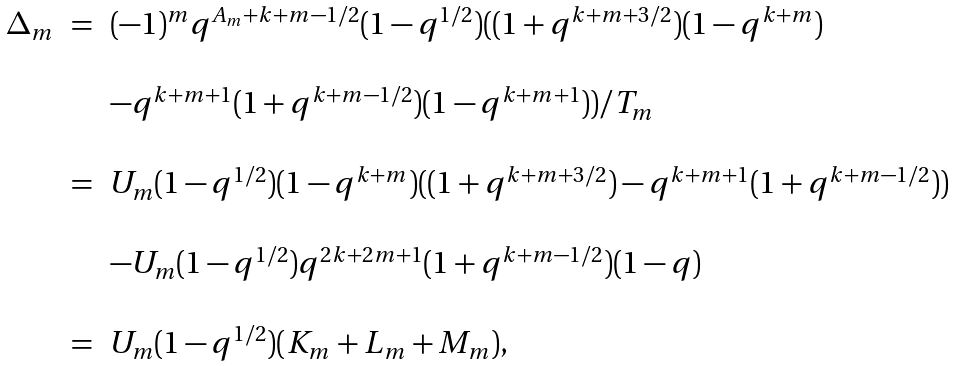<formula> <loc_0><loc_0><loc_500><loc_500>\begin{array} { c c l } \Delta _ { m } & = & ( - 1 ) ^ { m } q ^ { A _ { m } + k + m - 1 / 2 } ( 1 - q ^ { 1 / 2 } ) ( ( 1 + q ^ { k + m + 3 / 2 } ) ( 1 - q ^ { k + m } ) \\ \\ & & - q ^ { k + m + 1 } ( 1 + q ^ { k + m - 1 / 2 } ) ( 1 - q ^ { k + m + 1 } ) ) / T _ { m } \\ \\ & = & U _ { m } ( 1 - q ^ { 1 / 2 } ) ( 1 - q ^ { k + m } ) ( ( 1 + q ^ { k + m + 3 / 2 } ) - q ^ { k + m + 1 } ( 1 + q ^ { k + m - 1 / 2 } ) ) \\ \\ & & - U _ { m } ( 1 - q ^ { 1 / 2 } ) q ^ { 2 k + 2 m + 1 } ( 1 + q ^ { k + m - 1 / 2 } ) ( 1 - q ) \\ \\ & = & U _ { m } ( 1 - q ^ { 1 / 2 } ) ( K _ { m } + L _ { m } + M _ { m } ) , \end{array}</formula> 